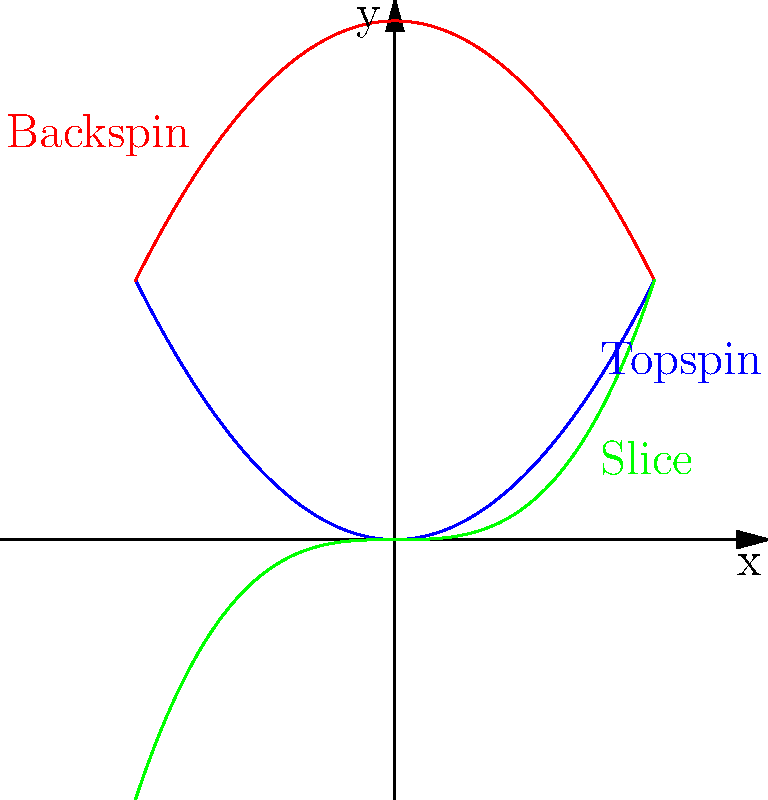Which spin technique would be most effective for a Czech player trying to hit a passing shot against a net-rushing opponent on a clay court? To determine the most effective spin technique for a passing shot against a net-rushing opponent on clay, let's consider each spin type:

1. Topspin (blue curve):
   - Creates a downward force, causing the ball to dip sharply
   - Increases bounce height after impact
   - Provides more control and margin for error

2. Backspin (red curve):
   - Creates an upward force, causing the ball to float
   - Decreases bounce height after impact
   - Effective for drop shots but less suitable for passing shots

3. Slice (green curve):
   - Creates sideways spin, causing the ball to curve laterally
   - Keeps the ball low after bouncing
   - Can be effective for wrong-footing opponents

For a passing shot on clay:
- Topspin allows for a higher net clearance while still dropping the ball in the court
- The high bounce on clay is accentuated by topspin, making it difficult for the opponent to volley
- Clay's slower surface gives more time for topspin shots to dip, increasing their effectiveness

Given these factors, topspin would be the most effective technique for a passing shot against a net-rushing opponent on clay.
Answer: Topspin 